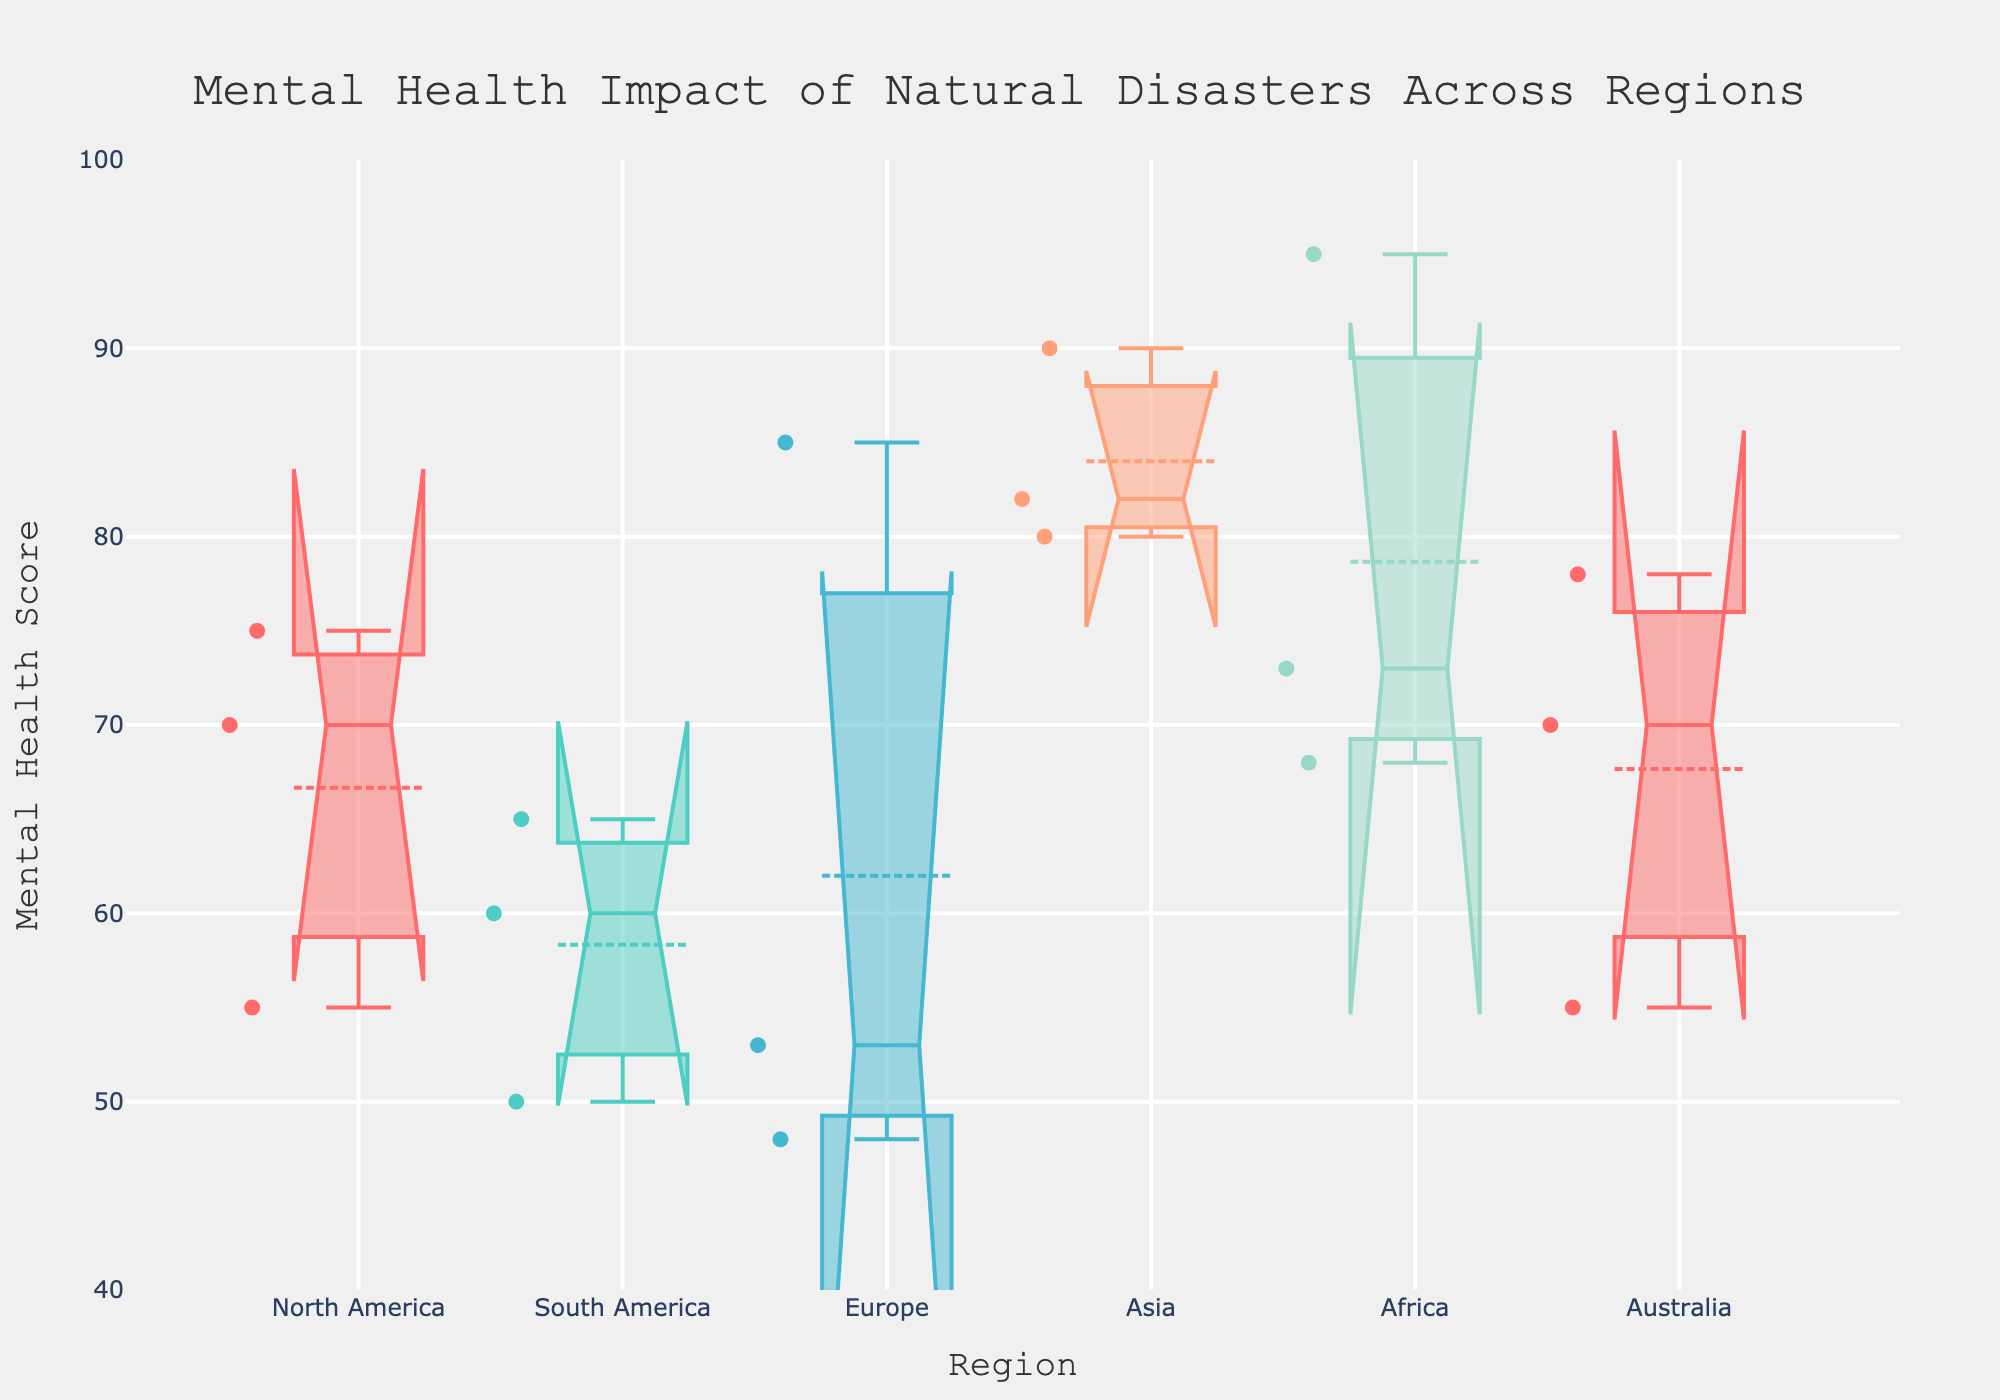Which region has the highest median mental health score? To find the region with the highest median mental health score, look at the middle value where the box is divided by the median line for each region. The region with the median line at the highest point is Africa.
Answer: Africa What is the title of the plot? The title of the plot is usually located at the top center of the figure. From the information provided, the title is "Mental Health Impact of Natural Disasters Across Regions."
Answer: Mental Health Impact of Natural Disasters Across Regions How does the interquartile range (IQR) of North America's mental health scores compare to that of Europe's? The Interquartile Range (IQR) is the range between the first quartile (Q1) and the third quartile (Q3). For North America, it looks larger, indicating a wider spread between the central 50% of data points compared to Europe.
Answer: North America's IQR is larger than Europe's Which region has the smallest range of mental health scores? To identify the region with the smallest range, observe the whiskers which show the overall spread. Determine which region has the shortest distance between its highest and lowest values. Europe appears to have the smallest range.
Answer: Europe What is the mental health score for the 'L'Aquila Earthquake' in Europe? The 'L'Aquila Earthquake' in Europe corresponds to one of the individual points in the box plot for Europe. Referencing the provided data, the score for this event is 85.
Answer: 85 Which region has the most spread data points outside the interquartile range (IQR)? Data points outside the IQR are typically shown as outliers. Compare the number of outliers (points beyond the whiskers) in each region. Europe has the most spread data points outside the IQR.
Answer: Europe What is the lower bound of the notches for the Asia region? Notches around the median indicate the confidence interval of the median. Find the lower end of the notch in the Asia region; it is around 70.
Answer: Around 70 How does the median mental health score of South America compare to that of North America? Locate the median lines within the boxes for both South America and North America. The median for South America is slightly lower than that of North America.
Answer: South America's median is lower Compare the upper bounds of the whiskers for Africa and Asia. Which has a higher bound? Whiskers extend from the box to the highest and lowest values excluding outliers. Compare the top ends of the whiskers for Africa and Asia. Africa's upper bound is higher.
Answer: Africa What are the colors used in the plot, and what do they represent? The plot uses different colors to differentiate between regions. Referencing the code, the colors are inspired by an artist's palette, including shades like red, teal, blue, light orange, and sea green.
Answer: Red, teal, blue, light orange, sea green represent different regions 